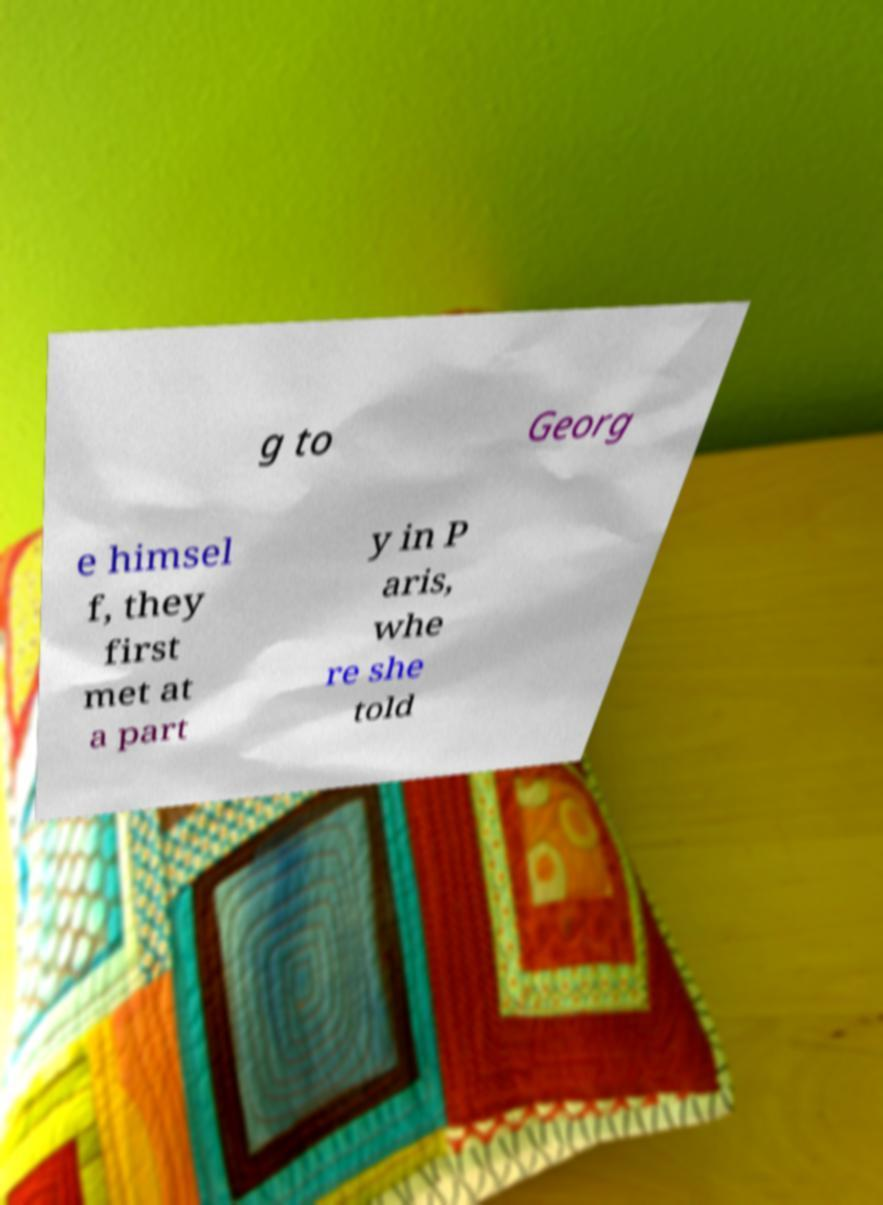Can you read and provide the text displayed in the image?This photo seems to have some interesting text. Can you extract and type it out for me? g to Georg e himsel f, they first met at a part y in P aris, whe re she told 